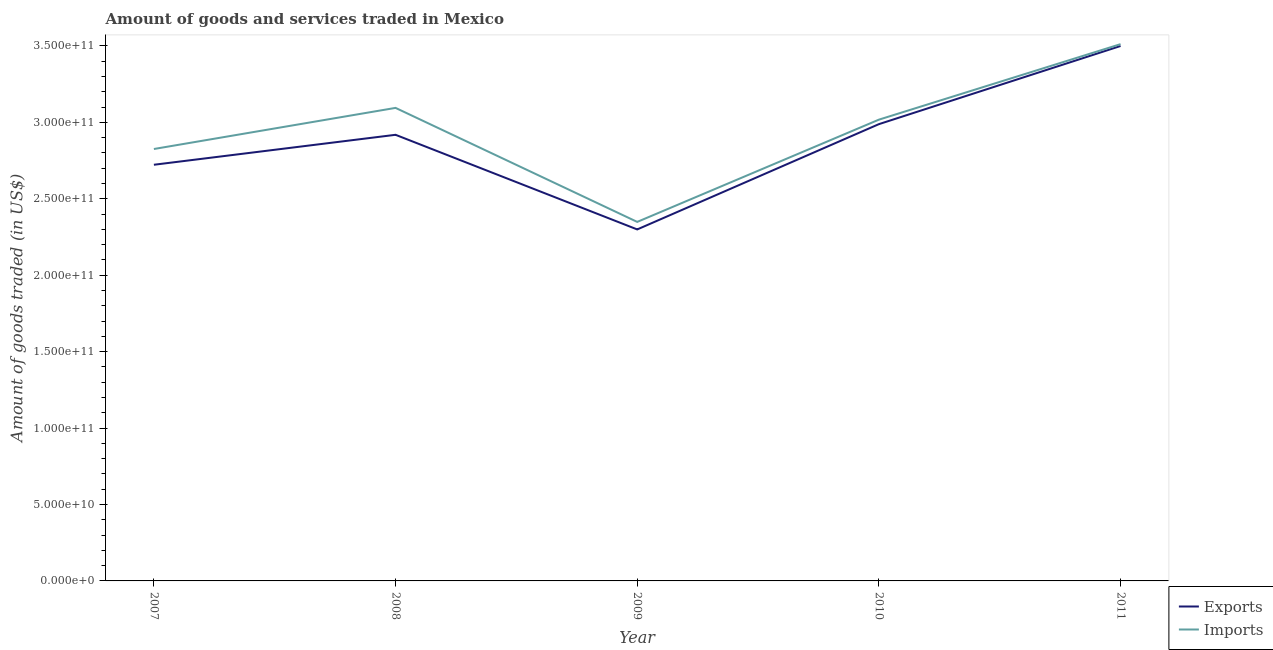How many different coloured lines are there?
Your answer should be very brief. 2. Does the line corresponding to amount of goods exported intersect with the line corresponding to amount of goods imported?
Ensure brevity in your answer.  No. What is the amount of goods imported in 2007?
Provide a succinct answer. 2.83e+11. Across all years, what is the maximum amount of goods imported?
Give a very brief answer. 3.51e+11. Across all years, what is the minimum amount of goods exported?
Make the answer very short. 2.30e+11. What is the total amount of goods exported in the graph?
Provide a succinct answer. 1.44e+12. What is the difference between the amount of goods exported in 2008 and that in 2011?
Keep it short and to the point. -5.81e+1. What is the difference between the amount of goods exported in 2010 and the amount of goods imported in 2008?
Give a very brief answer. -1.06e+1. What is the average amount of goods imported per year?
Provide a succinct answer. 2.96e+11. In the year 2010, what is the difference between the amount of goods imported and amount of goods exported?
Provide a short and direct response. 2.94e+09. What is the ratio of the amount of goods exported in 2010 to that in 2011?
Keep it short and to the point. 0.85. Is the difference between the amount of goods exported in 2008 and 2011 greater than the difference between the amount of goods imported in 2008 and 2011?
Provide a short and direct response. No. What is the difference between the highest and the second highest amount of goods exported?
Keep it short and to the point. 5.11e+1. What is the difference between the highest and the lowest amount of goods imported?
Give a very brief answer. 1.16e+11. In how many years, is the amount of goods imported greater than the average amount of goods imported taken over all years?
Offer a very short reply. 3. Is the sum of the amount of goods imported in 2008 and 2010 greater than the maximum amount of goods exported across all years?
Make the answer very short. Yes. Is the amount of goods exported strictly greater than the amount of goods imported over the years?
Offer a very short reply. No. What is the difference between two consecutive major ticks on the Y-axis?
Keep it short and to the point. 5.00e+1. Does the graph contain any zero values?
Make the answer very short. No. Does the graph contain grids?
Offer a terse response. No. Where does the legend appear in the graph?
Ensure brevity in your answer.  Bottom right. How many legend labels are there?
Provide a short and direct response. 2. How are the legend labels stacked?
Offer a very short reply. Vertical. What is the title of the graph?
Your answer should be compact. Amount of goods and services traded in Mexico. Does "Exports of goods" appear as one of the legend labels in the graph?
Keep it short and to the point. No. What is the label or title of the X-axis?
Offer a terse response. Year. What is the label or title of the Y-axis?
Give a very brief answer. Amount of goods traded (in US$). What is the Amount of goods traded (in US$) in Exports in 2007?
Keep it short and to the point. 2.72e+11. What is the Amount of goods traded (in US$) in Imports in 2007?
Keep it short and to the point. 2.83e+11. What is the Amount of goods traded (in US$) of Exports in 2008?
Offer a very short reply. 2.92e+11. What is the Amount of goods traded (in US$) in Imports in 2008?
Your response must be concise. 3.10e+11. What is the Amount of goods traded (in US$) in Exports in 2009?
Provide a short and direct response. 2.30e+11. What is the Amount of goods traded (in US$) in Imports in 2009?
Your answer should be very brief. 2.35e+11. What is the Amount of goods traded (in US$) of Exports in 2010?
Offer a very short reply. 2.99e+11. What is the Amount of goods traded (in US$) of Imports in 2010?
Make the answer very short. 3.02e+11. What is the Amount of goods traded (in US$) in Exports in 2011?
Ensure brevity in your answer.  3.50e+11. What is the Amount of goods traded (in US$) in Imports in 2011?
Your answer should be compact. 3.51e+11. Across all years, what is the maximum Amount of goods traded (in US$) in Exports?
Keep it short and to the point. 3.50e+11. Across all years, what is the maximum Amount of goods traded (in US$) in Imports?
Give a very brief answer. 3.51e+11. Across all years, what is the minimum Amount of goods traded (in US$) of Exports?
Your answer should be very brief. 2.30e+11. Across all years, what is the minimum Amount of goods traded (in US$) in Imports?
Give a very brief answer. 2.35e+11. What is the total Amount of goods traded (in US$) in Exports in the graph?
Ensure brevity in your answer.  1.44e+12. What is the total Amount of goods traded (in US$) in Imports in the graph?
Give a very brief answer. 1.48e+12. What is the difference between the Amount of goods traded (in US$) of Exports in 2007 and that in 2008?
Your answer should be compact. -1.96e+1. What is the difference between the Amount of goods traded (in US$) of Imports in 2007 and that in 2008?
Your response must be concise. -2.69e+1. What is the difference between the Amount of goods traded (in US$) of Exports in 2007 and that in 2009?
Ensure brevity in your answer.  4.23e+1. What is the difference between the Amount of goods traded (in US$) of Imports in 2007 and that in 2009?
Make the answer very short. 4.77e+1. What is the difference between the Amount of goods traded (in US$) of Exports in 2007 and that in 2010?
Provide a short and direct response. -2.66e+1. What is the difference between the Amount of goods traded (in US$) of Imports in 2007 and that in 2010?
Provide a succinct answer. -1.92e+1. What is the difference between the Amount of goods traded (in US$) of Exports in 2007 and that in 2011?
Provide a succinct answer. -7.77e+1. What is the difference between the Amount of goods traded (in US$) in Imports in 2007 and that in 2011?
Make the answer very short. -6.86e+1. What is the difference between the Amount of goods traded (in US$) of Exports in 2008 and that in 2009?
Your answer should be compact. 6.19e+1. What is the difference between the Amount of goods traded (in US$) of Imports in 2008 and that in 2009?
Provide a succinct answer. 7.46e+1. What is the difference between the Amount of goods traded (in US$) in Exports in 2008 and that in 2010?
Give a very brief answer. -6.97e+09. What is the difference between the Amount of goods traded (in US$) in Imports in 2008 and that in 2010?
Your response must be concise. 7.70e+09. What is the difference between the Amount of goods traded (in US$) of Exports in 2008 and that in 2011?
Your answer should be very brief. -5.81e+1. What is the difference between the Amount of goods traded (in US$) of Imports in 2008 and that in 2011?
Give a very brief answer. -4.17e+1. What is the difference between the Amount of goods traded (in US$) of Exports in 2009 and that in 2010?
Your answer should be very brief. -6.89e+1. What is the difference between the Amount of goods traded (in US$) in Imports in 2009 and that in 2010?
Ensure brevity in your answer.  -6.69e+1. What is the difference between the Amount of goods traded (in US$) of Exports in 2009 and that in 2011?
Give a very brief answer. -1.20e+11. What is the difference between the Amount of goods traded (in US$) of Imports in 2009 and that in 2011?
Offer a very short reply. -1.16e+11. What is the difference between the Amount of goods traded (in US$) in Exports in 2010 and that in 2011?
Ensure brevity in your answer.  -5.11e+1. What is the difference between the Amount of goods traded (in US$) in Imports in 2010 and that in 2011?
Ensure brevity in your answer.  -4.94e+1. What is the difference between the Amount of goods traded (in US$) in Exports in 2007 and the Amount of goods traded (in US$) in Imports in 2008?
Provide a succinct answer. -3.72e+1. What is the difference between the Amount of goods traded (in US$) in Exports in 2007 and the Amount of goods traded (in US$) in Imports in 2009?
Keep it short and to the point. 3.74e+1. What is the difference between the Amount of goods traded (in US$) of Exports in 2007 and the Amount of goods traded (in US$) of Imports in 2010?
Keep it short and to the point. -2.95e+1. What is the difference between the Amount of goods traded (in US$) of Exports in 2007 and the Amount of goods traded (in US$) of Imports in 2011?
Keep it short and to the point. -7.89e+1. What is the difference between the Amount of goods traded (in US$) in Exports in 2008 and the Amount of goods traded (in US$) in Imports in 2009?
Keep it short and to the point. 5.70e+1. What is the difference between the Amount of goods traded (in US$) in Exports in 2008 and the Amount of goods traded (in US$) in Imports in 2010?
Your answer should be compact. -9.92e+09. What is the difference between the Amount of goods traded (in US$) of Exports in 2008 and the Amount of goods traded (in US$) of Imports in 2011?
Offer a very short reply. -5.93e+1. What is the difference between the Amount of goods traded (in US$) of Exports in 2009 and the Amount of goods traded (in US$) of Imports in 2010?
Ensure brevity in your answer.  -7.18e+1. What is the difference between the Amount of goods traded (in US$) of Exports in 2009 and the Amount of goods traded (in US$) of Imports in 2011?
Ensure brevity in your answer.  -1.21e+11. What is the difference between the Amount of goods traded (in US$) in Exports in 2010 and the Amount of goods traded (in US$) in Imports in 2011?
Offer a very short reply. -5.23e+1. What is the average Amount of goods traded (in US$) of Exports per year?
Provide a short and direct response. 2.89e+11. What is the average Amount of goods traded (in US$) in Imports per year?
Provide a succinct answer. 2.96e+11. In the year 2007, what is the difference between the Amount of goods traded (in US$) of Exports and Amount of goods traded (in US$) of Imports?
Keep it short and to the point. -1.03e+1. In the year 2008, what is the difference between the Amount of goods traded (in US$) of Exports and Amount of goods traded (in US$) of Imports?
Your response must be concise. -1.76e+1. In the year 2009, what is the difference between the Amount of goods traded (in US$) in Exports and Amount of goods traded (in US$) in Imports?
Give a very brief answer. -4.93e+09. In the year 2010, what is the difference between the Amount of goods traded (in US$) in Exports and Amount of goods traded (in US$) in Imports?
Offer a very short reply. -2.94e+09. In the year 2011, what is the difference between the Amount of goods traded (in US$) in Exports and Amount of goods traded (in US$) in Imports?
Your answer should be very brief. -1.20e+09. What is the ratio of the Amount of goods traded (in US$) of Exports in 2007 to that in 2008?
Your answer should be very brief. 0.93. What is the ratio of the Amount of goods traded (in US$) of Imports in 2007 to that in 2008?
Ensure brevity in your answer.  0.91. What is the ratio of the Amount of goods traded (in US$) in Exports in 2007 to that in 2009?
Give a very brief answer. 1.18. What is the ratio of the Amount of goods traded (in US$) in Imports in 2007 to that in 2009?
Ensure brevity in your answer.  1.2. What is the ratio of the Amount of goods traded (in US$) in Exports in 2007 to that in 2010?
Offer a terse response. 0.91. What is the ratio of the Amount of goods traded (in US$) of Imports in 2007 to that in 2010?
Your answer should be compact. 0.94. What is the ratio of the Amount of goods traded (in US$) in Exports in 2007 to that in 2011?
Provide a short and direct response. 0.78. What is the ratio of the Amount of goods traded (in US$) in Imports in 2007 to that in 2011?
Your response must be concise. 0.8. What is the ratio of the Amount of goods traded (in US$) of Exports in 2008 to that in 2009?
Your answer should be compact. 1.27. What is the ratio of the Amount of goods traded (in US$) in Imports in 2008 to that in 2009?
Your answer should be very brief. 1.32. What is the ratio of the Amount of goods traded (in US$) in Exports in 2008 to that in 2010?
Provide a succinct answer. 0.98. What is the ratio of the Amount of goods traded (in US$) in Imports in 2008 to that in 2010?
Provide a short and direct response. 1.03. What is the ratio of the Amount of goods traded (in US$) in Exports in 2008 to that in 2011?
Your answer should be compact. 0.83. What is the ratio of the Amount of goods traded (in US$) of Imports in 2008 to that in 2011?
Make the answer very short. 0.88. What is the ratio of the Amount of goods traded (in US$) of Exports in 2009 to that in 2010?
Offer a terse response. 0.77. What is the ratio of the Amount of goods traded (in US$) in Imports in 2009 to that in 2010?
Your response must be concise. 0.78. What is the ratio of the Amount of goods traded (in US$) in Exports in 2009 to that in 2011?
Offer a terse response. 0.66. What is the ratio of the Amount of goods traded (in US$) in Imports in 2009 to that in 2011?
Make the answer very short. 0.67. What is the ratio of the Amount of goods traded (in US$) of Exports in 2010 to that in 2011?
Offer a terse response. 0.85. What is the ratio of the Amount of goods traded (in US$) in Imports in 2010 to that in 2011?
Your answer should be very brief. 0.86. What is the difference between the highest and the second highest Amount of goods traded (in US$) of Exports?
Your answer should be very brief. 5.11e+1. What is the difference between the highest and the second highest Amount of goods traded (in US$) in Imports?
Your answer should be compact. 4.17e+1. What is the difference between the highest and the lowest Amount of goods traded (in US$) in Exports?
Give a very brief answer. 1.20e+11. What is the difference between the highest and the lowest Amount of goods traded (in US$) of Imports?
Your response must be concise. 1.16e+11. 